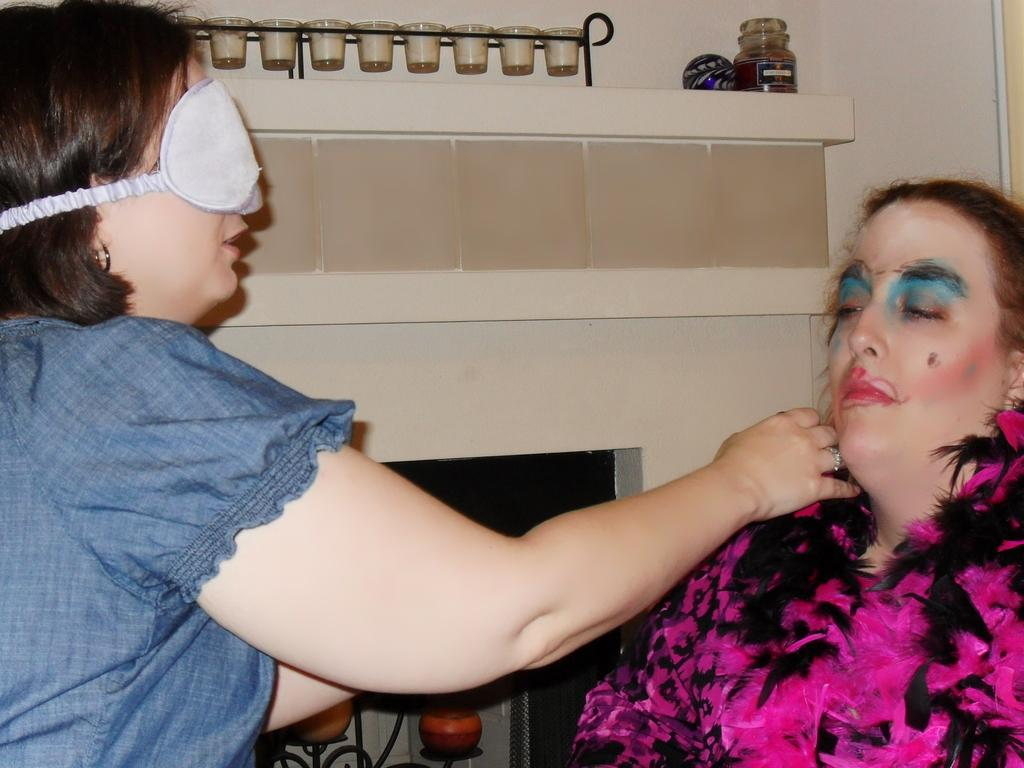How many women are in the image? There are two women in the image. Can you describe the appearance of one of the women? One of the women is wearing a blindfold. What object can be seen in the image besides the women? There is a bottle visible in the image. What else might be present in the image that is not specified? There are other unspecified things in the image. How many apples are on the table in the image? There is no table or apples present in the image. What type of currency is being exchanged in the image? There is no exchange of money or currency depicted in the image. 